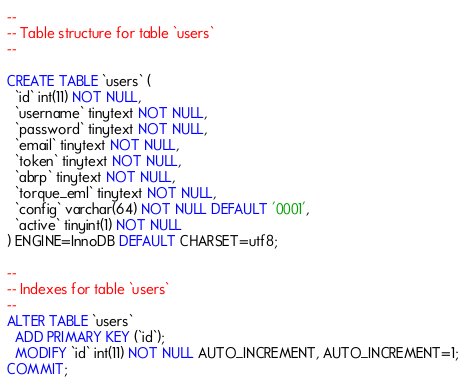<code> <loc_0><loc_0><loc_500><loc_500><_SQL_>--
-- Table structure for table `users`
--

CREATE TABLE `users` (
  `id` int(11) NOT NULL,
  `username` tinytext NOT NULL,
  `password` tinytext NOT NULL,
  `email` tinytext NOT NULL,
  `token` tinytext NOT NULL,
  `abrp` tinytext NOT NULL,
  `torque_eml` tinytext NOT NULL,
  `config` varchar(64) NOT NULL DEFAULT '0001',
  `active` tinyint(1) NOT NULL
) ENGINE=InnoDB DEFAULT CHARSET=utf8;

--
-- Indexes for table `users`
--
ALTER TABLE `users`
  ADD PRIMARY KEY (`id`);
  MODIFY `id` int(11) NOT NULL AUTO_INCREMENT, AUTO_INCREMENT=1;
COMMIT;</code> 